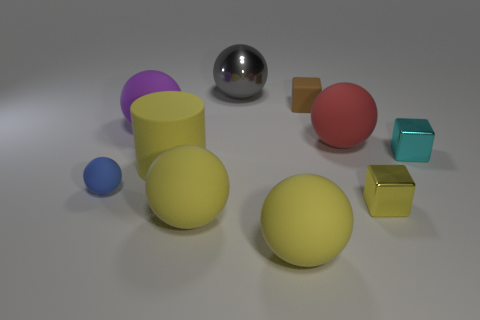What is the size of the metallic thing that is the same color as the large rubber cylinder?
Give a very brief answer. Small. There is a shiny object in front of the tiny block that is to the right of the tiny yellow object; how big is it?
Offer a very short reply. Small. Are there an equal number of big cylinders that are behind the small brown matte thing and big purple rubber balls?
Make the answer very short. No. How many other things are the same color as the big shiny sphere?
Offer a terse response. 0. Is the number of brown matte blocks on the left side of the big gray shiny sphere less than the number of blue matte blocks?
Your answer should be compact. No. Are there any red matte objects that have the same size as the matte cylinder?
Offer a very short reply. Yes. There is a large rubber cylinder; is its color the same as the tiny matte object behind the blue matte sphere?
Offer a terse response. No. What number of big gray spheres are on the right side of the small metallic thing that is in front of the tiny cyan metallic object?
Make the answer very short. 0. There is a tiny matte object that is on the left side of the large yellow rubber thing behind the blue object; what color is it?
Offer a very short reply. Blue. What is the tiny thing that is both in front of the large cylinder and right of the purple object made of?
Provide a succinct answer. Metal. 